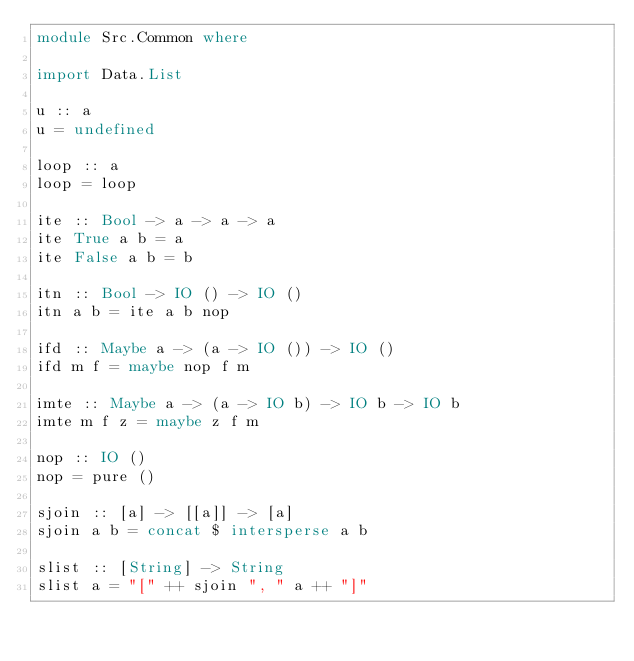<code> <loc_0><loc_0><loc_500><loc_500><_Haskell_>module Src.Common where

import Data.List

u :: a
u = undefined

loop :: a
loop = loop

ite :: Bool -> a -> a -> a
ite True a b = a
ite False a b = b

itn :: Bool -> IO () -> IO ()
itn a b = ite a b nop

ifd :: Maybe a -> (a -> IO ()) -> IO ()
ifd m f = maybe nop f m

imte :: Maybe a -> (a -> IO b) -> IO b -> IO b
imte m f z = maybe z f m

nop :: IO ()
nop = pure ()

sjoin :: [a] -> [[a]] -> [a]
sjoin a b = concat $ intersperse a b

slist :: [String] -> String
slist a = "[" ++ sjoin ", " a ++ "]"</code> 